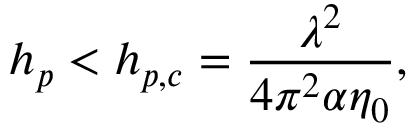Convert formula to latex. <formula><loc_0><loc_0><loc_500><loc_500>h _ { p } < h _ { p , c } = \frac { \lambda ^ { 2 } } { 4 \pi ^ { 2 } \alpha \eta _ { 0 } } ,</formula> 